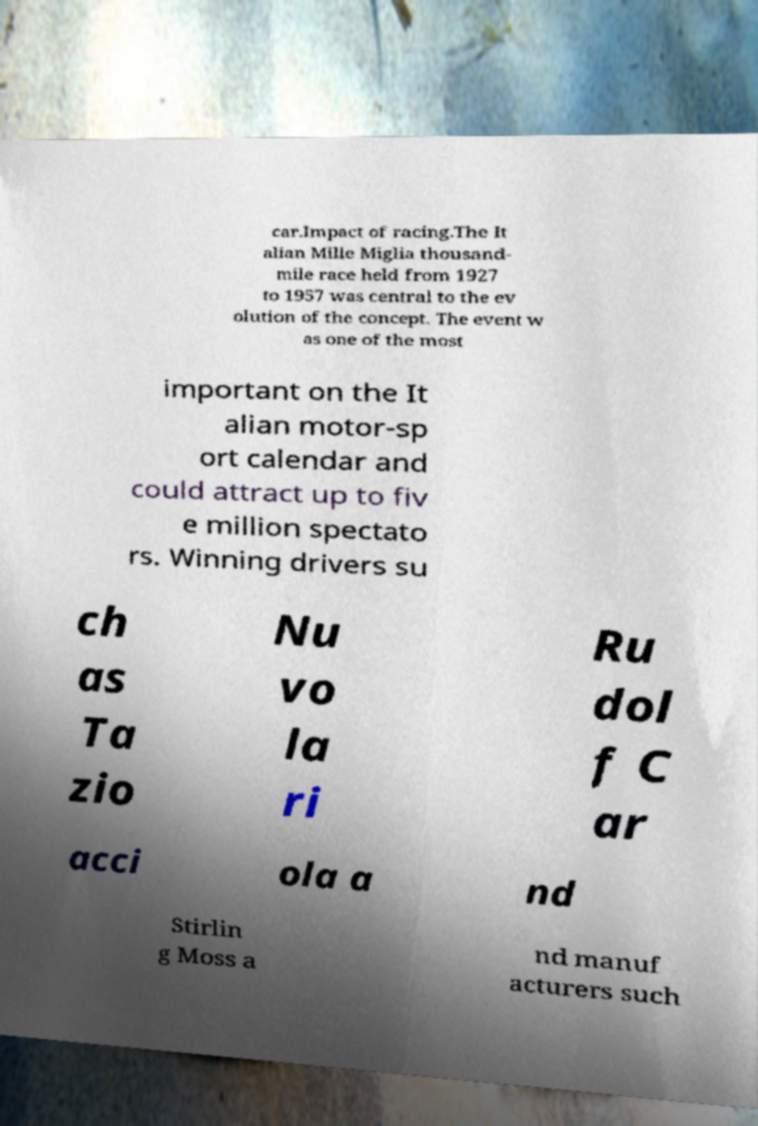Please read and relay the text visible in this image. What does it say? car.Impact of racing.The It alian Mille Miglia thousand- mile race held from 1927 to 1957 was central to the ev olution of the concept. The event w as one of the most important on the It alian motor-sp ort calendar and could attract up to fiv e million spectato rs. Winning drivers su ch as Ta zio Nu vo la ri Ru dol f C ar acci ola a nd Stirlin g Moss a nd manuf acturers such 